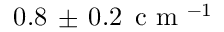<formula> <loc_0><loc_0><loc_500><loc_500>0 . 8 \, \pm \, 0 . 2 \, c m ^ { - 1 }</formula> 